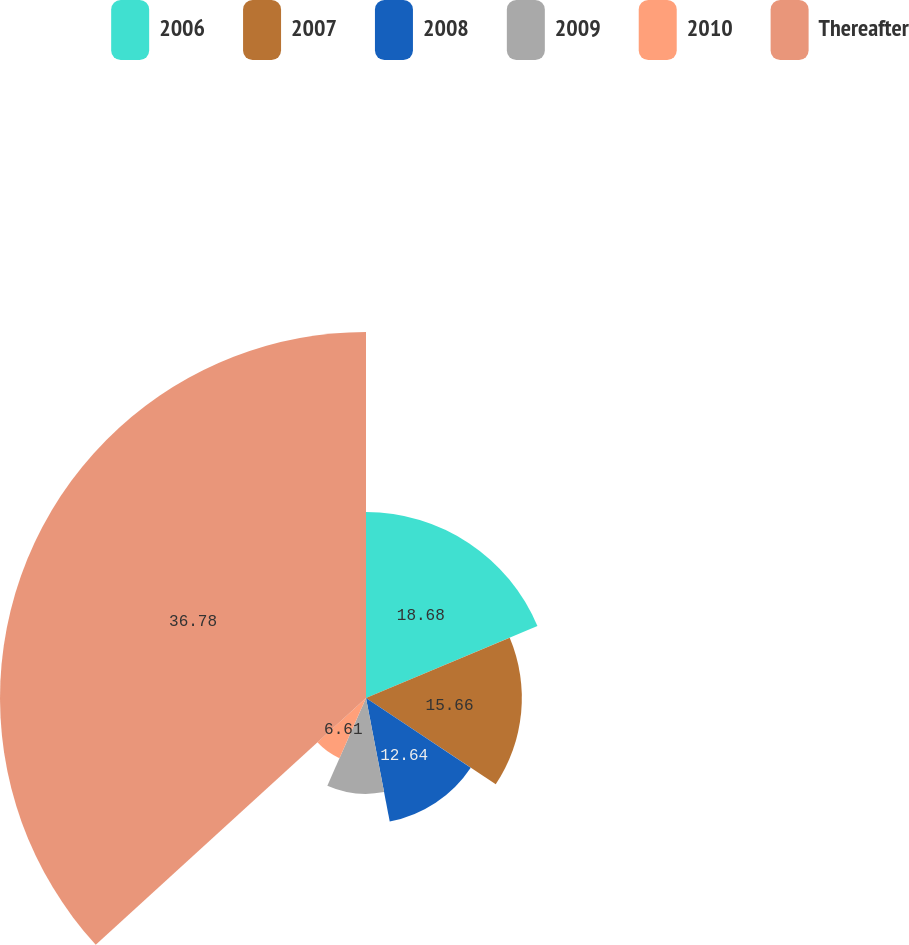Convert chart to OTSL. <chart><loc_0><loc_0><loc_500><loc_500><pie_chart><fcel>2006<fcel>2007<fcel>2008<fcel>2009<fcel>2010<fcel>Thereafter<nl><fcel>18.68%<fcel>15.66%<fcel>12.64%<fcel>9.63%<fcel>6.61%<fcel>36.78%<nl></chart> 